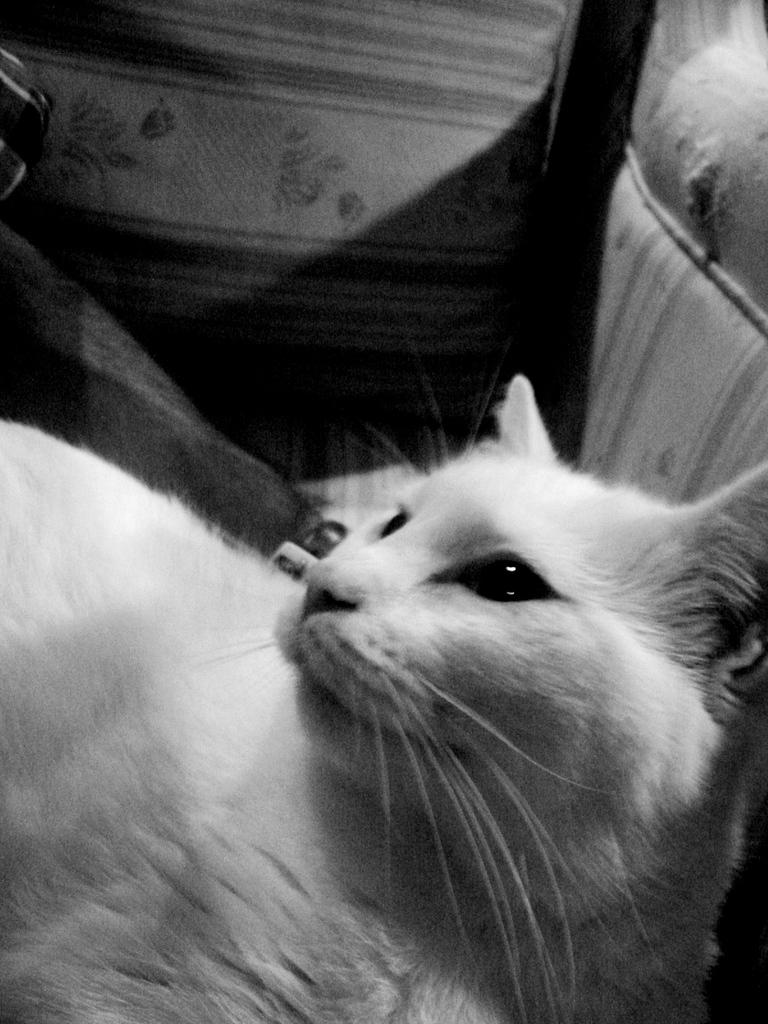What type of animal is in the image? There is a cat in the image. Can you describe the color of the cat? The cat is white in color. What type of vegetable is the cat eating in the image? There is no vegetable, such as cabbage, present in the image, and the cat is not eating anything. 